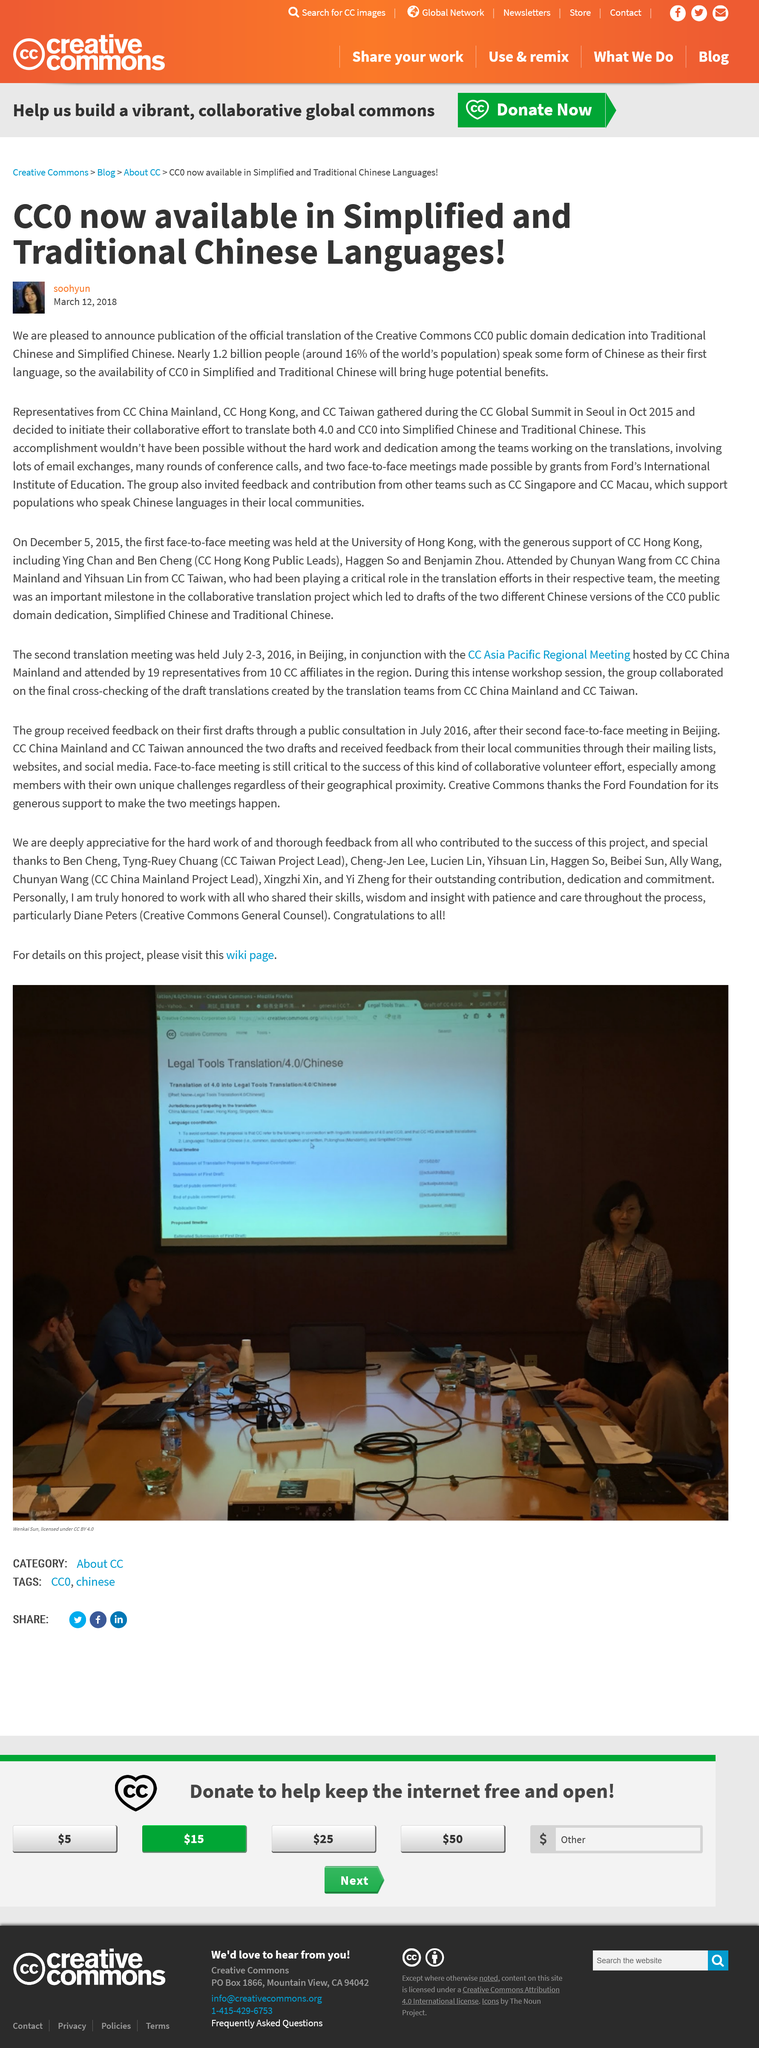Specify some key components in this picture. The chapters of CC involved in this project were CC China Mainland, CC Hong Kong, CC Taiwan, CC Singapore, and CC Macau. The CC licenses have been translated into both simplified and traditional Chinese. The group sought feedback and contributions from CC Singapore and CC Macau. 